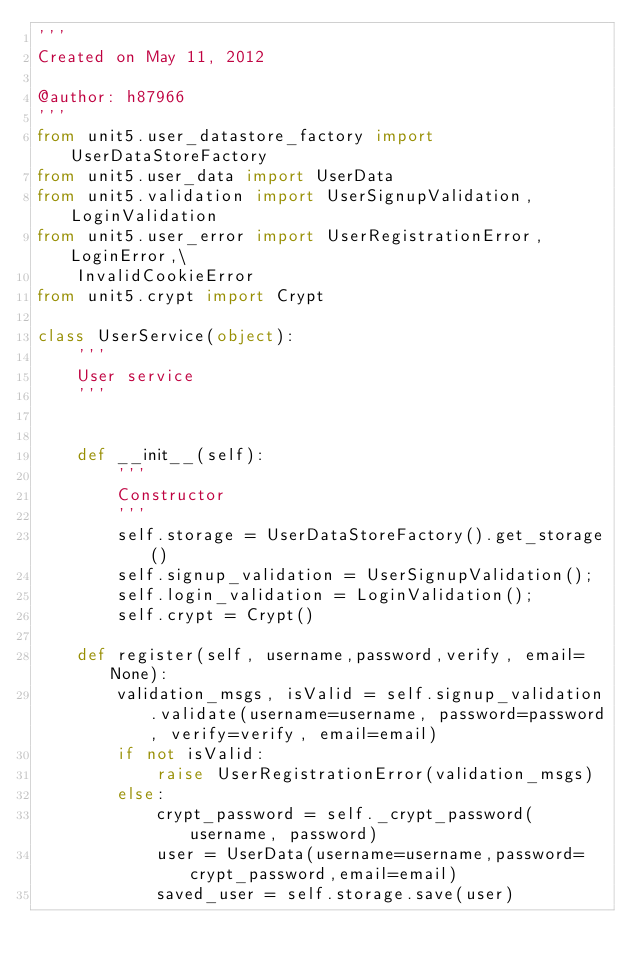Convert code to text. <code><loc_0><loc_0><loc_500><loc_500><_Python_>'''
Created on May 11, 2012

@author: h87966
'''
from unit5.user_datastore_factory import UserDataStoreFactory
from unit5.user_data import UserData
from unit5.validation import UserSignupValidation, LoginValidation
from unit5.user_error import UserRegistrationError, LoginError,\
    InvalidCookieError
from unit5.crypt import Crypt

class UserService(object):
    '''
    User service
    '''
    

    def __init__(self):
        '''
        Constructor
        '''
        self.storage = UserDataStoreFactory().get_storage()
        self.signup_validation = UserSignupValidation();
        self.login_validation = LoginValidation();
        self.crypt = Crypt()
        
    def register(self, username,password,verify, email=None):
        validation_msgs, isValid = self.signup_validation.validate(username=username, password=password, verify=verify, email=email)
        if not isValid:
            raise UserRegistrationError(validation_msgs)
        else:
            crypt_password = self._crypt_password(username, password)
            user = UserData(username=username,password=crypt_password,email=email)
            saved_user = self.storage.save(user)</code> 